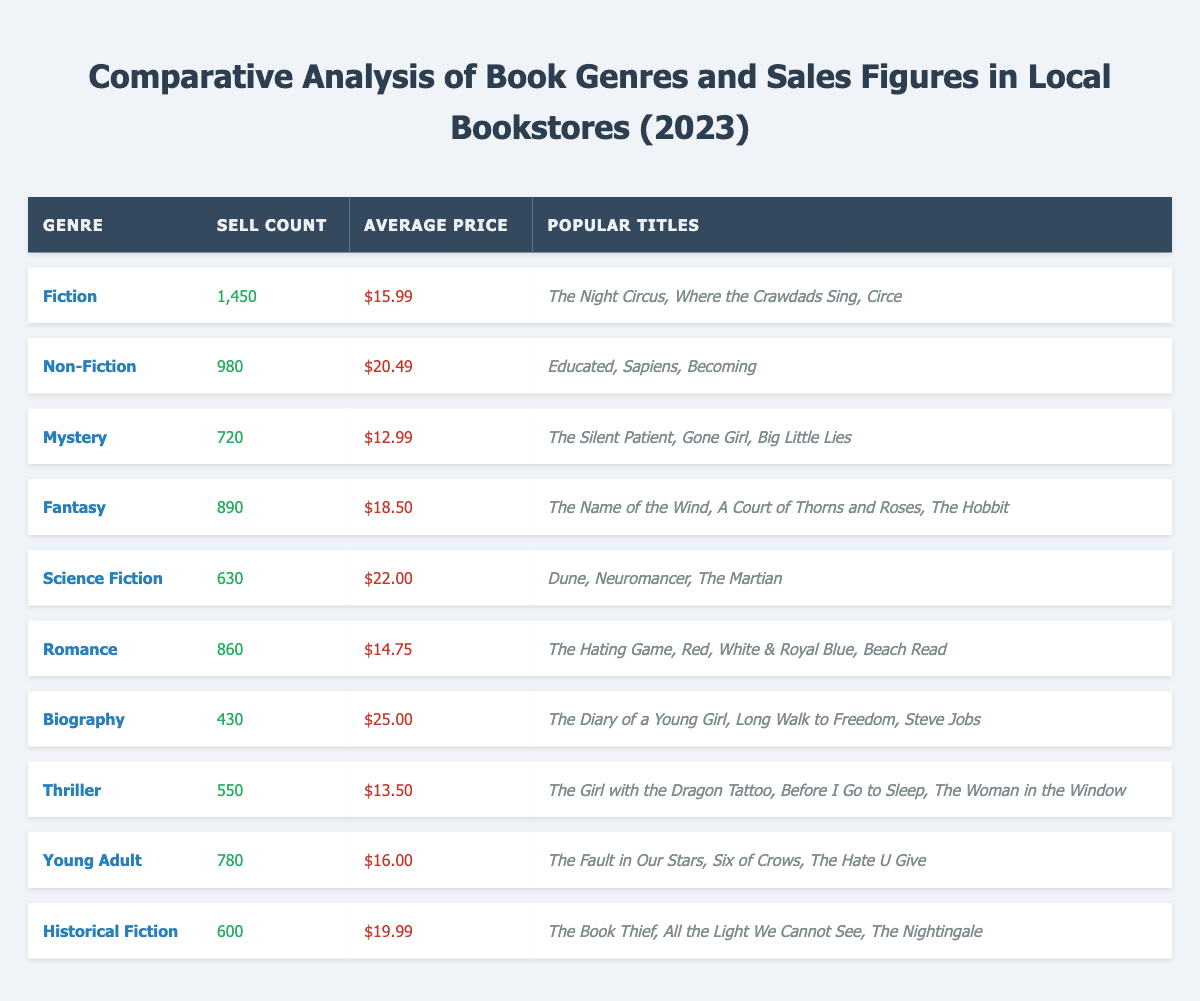What is the genre with the highest sell count? By reviewing the sell count for each genre listed in the table, Fiction has the highest sell count of 1450.
Answer: Fiction Which genre has the lowest average price? The average price is lowest for the Mystery genre at $12.99, as shown in the average price column.
Answer: Mystery How many more copies did Fiction sell than Non-Fiction? Fiction sold 1450 copies, and Non-Fiction sold 980 copies. The difference is 1450 - 980 = 470.
Answer: 470 What is the average sell count of all genres in the table? Adding all the sell counts together (1450 + 980 + 720 + 890 + 630 + 860 + 430 + 550 + 780 + 600 =  7,610) and dividing by the number of genres (10) gives an average of 761.
Answer: 761 Does the Romance genre have a higher sell count than the Historical Fiction genre? Romance sold 860 copies while Historical Fiction sold 600 copies. Since 860 is greater than 600, the statement is true.
Answer: Yes Which genre has the most popular titles listed? The table mentions three popular titles for every genre, meaning all genres are equal in the number of popular titles.
Answer: All genres are equal What is the total sell count of the top three genres? The top three genres by sell count are Fiction (1450), Non-Fiction (980), and Fantasy (890). Summing these gives 1450 + 980 + 890 = 3320.
Answer: 3320 How does the average price of Science Fiction compare to the average price of Biography? The average price for Science Fiction is $22.00 and for Biography is $25.00. Since $22.00 is less than $25.00, the Science Fiction genre is cheaper.
Answer: Science Fiction is cheaper Which genre has a sell count that is less than 700? Reviewing the sell counts, Science Fiction (630) and Biography (430) both have sell counts below 700.
Answer: Science Fiction and Biography What is the total sales revenue for the Romance genre? To calculate the revenue for the Romance genre, multiply the sell count (860) by the average price ($14.75): 860 * 14.75 = $12,755.
Answer: $12,755 